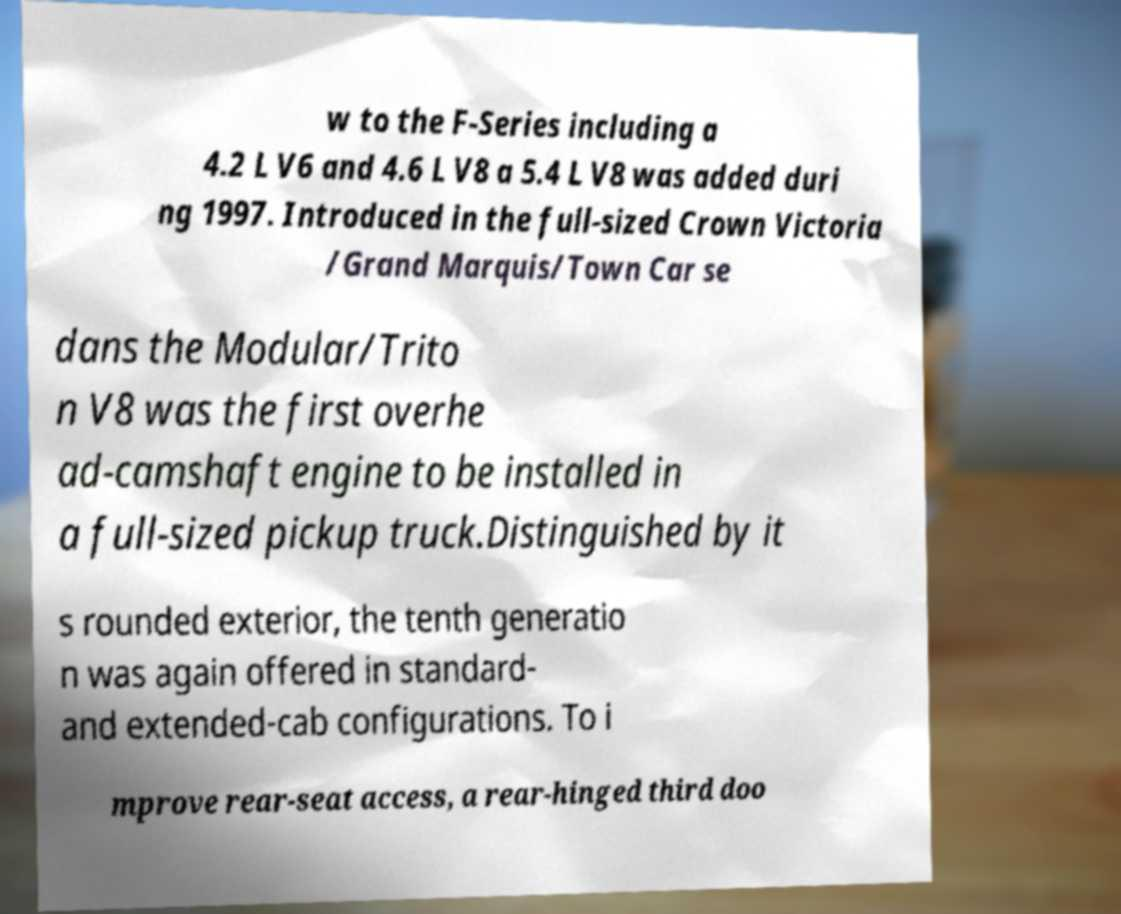There's text embedded in this image that I need extracted. Can you transcribe it verbatim? w to the F-Series including a 4.2 L V6 and 4.6 L V8 a 5.4 L V8 was added duri ng 1997. Introduced in the full-sized Crown Victoria /Grand Marquis/Town Car se dans the Modular/Trito n V8 was the first overhe ad-camshaft engine to be installed in a full-sized pickup truck.Distinguished by it s rounded exterior, the tenth generatio n was again offered in standard- and extended-cab configurations. To i mprove rear-seat access, a rear-hinged third doo 